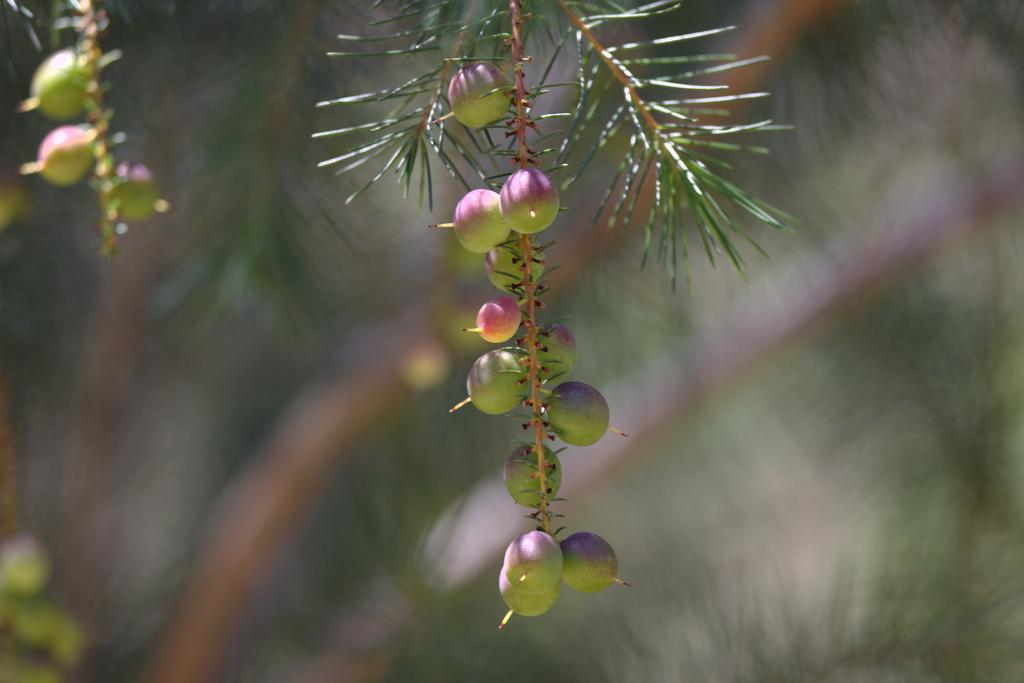What type of tree is depicted in the image? There is a yew family tree in the image. What colors are the fruits on the yew family tree? The fruits on the yew family tree have violet and green colors. Can you describe the background of the image? The background of the image is blurred. How many hooks are attached to the square door in the image? There is no square door or hooks present in the image. 